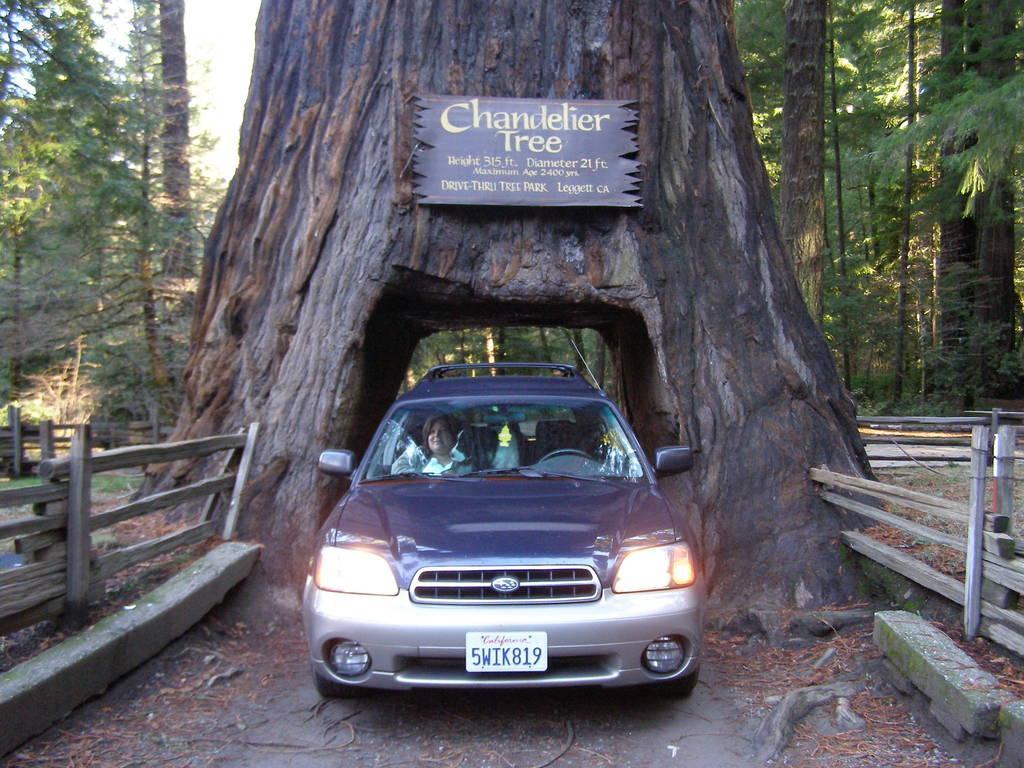How would you summarize this image in a sentence or two? In this image we can see a person sitting in the car is moving on the road which is coming from the tree trunk where we can see a board, we can see wooden fence, trees and the sky in the background. 